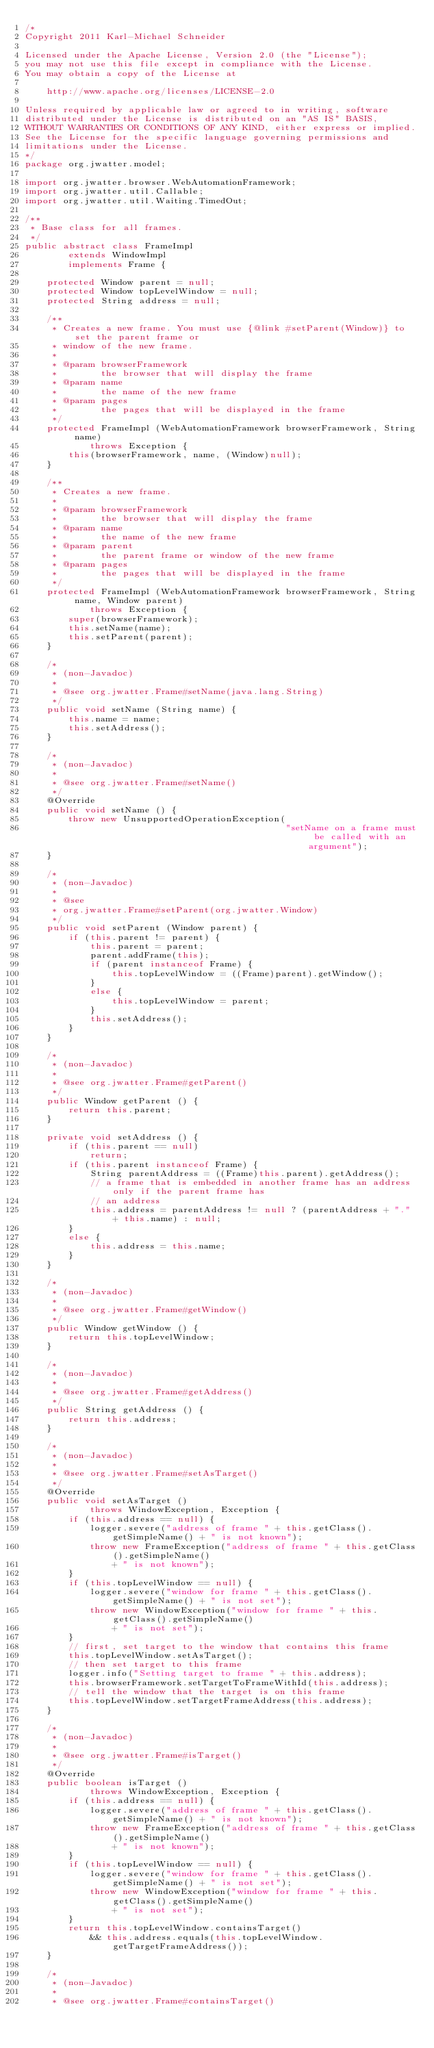Convert code to text. <code><loc_0><loc_0><loc_500><loc_500><_Java_>/*
Copyright 2011 Karl-Michael Schneider

Licensed under the Apache License, Version 2.0 (the "License");
you may not use this file except in compliance with the License.
You may obtain a copy of the License at

    http://www.apache.org/licenses/LICENSE-2.0

Unless required by applicable law or agreed to in writing, software
distributed under the License is distributed on an "AS IS" BASIS,
WITHOUT WARRANTIES OR CONDITIONS OF ANY KIND, either express or implied.
See the License for the specific language governing permissions and
limitations under the License.
*/
package org.jwatter.model;

import org.jwatter.browser.WebAutomationFramework;
import org.jwatter.util.Callable;
import org.jwatter.util.Waiting.TimedOut;

/**
 * Base class for all frames.
 */
public abstract class FrameImpl
        extends WindowImpl
        implements Frame {

    protected Window parent = null;
    protected Window topLevelWindow = null;
    protected String address = null;

    /**
     * Creates a new frame. You must use {@link #setParent(Window)} to set the parent frame or
     * window of the new frame.
     * 
     * @param browserFramework
     *        the browser that will display the frame
     * @param name
     *        the name of the new frame
     * @param pages
     *        the pages that will be displayed in the frame
     */
    protected FrameImpl (WebAutomationFramework browserFramework, String name)
            throws Exception {
        this(browserFramework, name, (Window)null);
    }

    /**
     * Creates a new frame.
     * 
     * @param browserFramework
     *        the browser that will display the frame
     * @param name
     *        the name of the new frame
     * @param parent
     *        the parent frame or window of the new frame
     * @param pages
     *        the pages that will be displayed in the frame
     */
    protected FrameImpl (WebAutomationFramework browserFramework, String name, Window parent)
            throws Exception {
        super(browserFramework);
        this.setName(name);
        this.setParent(parent);
    }

    /*
     * (non-Javadoc)
     * 
     * @see org.jwatter.Frame#setName(java.lang.String)
     */
    public void setName (String name) {
        this.name = name;
        this.setAddress();
    }

    /*
     * (non-Javadoc)
     * 
     * @see org.jwatter.Frame#setName()
     */
    @Override
    public void setName () {
        throw new UnsupportedOperationException(
                                                "setName on a frame must be called with an argument");
    }

    /*
     * (non-Javadoc)
     * 
     * @see
     * org.jwatter.Frame#setParent(org.jwatter.Window)
     */
    public void setParent (Window parent) {
        if (this.parent != parent) {
            this.parent = parent;
            parent.addFrame(this);
            if (parent instanceof Frame) {
                this.topLevelWindow = ((Frame)parent).getWindow();
            }
            else {
                this.topLevelWindow = parent;
            }
            this.setAddress();
        }
    }

    /*
     * (non-Javadoc)
     * 
     * @see org.jwatter.Frame#getParent()
     */
    public Window getParent () {
        return this.parent;
    }

    private void setAddress () {
        if (this.parent == null)
            return;
        if (this.parent instanceof Frame) {
            String parentAddress = ((Frame)this.parent).getAddress();
            // a frame that is embedded in another frame has an address only if the parent frame has
            // an address
            this.address = parentAddress != null ? (parentAddress + "." + this.name) : null;
        }
        else {
            this.address = this.name;
        }
    }

    /*
     * (non-Javadoc)
     * 
     * @see org.jwatter.Frame#getWindow()
     */
    public Window getWindow () {
        return this.topLevelWindow;
    }

    /*
     * (non-Javadoc)
     * 
     * @see org.jwatter.Frame#getAddress()
     */
    public String getAddress () {
        return this.address;
    }

    /*
     * (non-Javadoc)
     * 
     * @see org.jwatter.Frame#setAsTarget()
     */
    @Override
    public void setAsTarget ()
            throws WindowException, Exception {
        if (this.address == null) {
            logger.severe("address of frame " + this.getClass().getSimpleName() + " is not known");
            throw new FrameException("address of frame " + this.getClass().getSimpleName()
                + " is not known");
        }
        if (this.topLevelWindow == null) {
            logger.severe("window for frame " + this.getClass().getSimpleName() + " is not set");
            throw new WindowException("window for frame " + this.getClass().getSimpleName()
                + " is not set");
        }
        // first, set target to the window that contains this frame
        this.topLevelWindow.setAsTarget();
        // then set target to this frame
        logger.info("Setting target to frame " + this.address);
        this.browserFramework.setTargetToFrameWithId(this.address);
        // tell the window that the target is on this frame
        this.topLevelWindow.setTargetFrameAddress(this.address);
    }

    /*
     * (non-Javadoc)
     * 
     * @see org.jwatter.Frame#isTarget()
     */
    @Override
    public boolean isTarget ()
            throws WindowException, Exception {
        if (this.address == null) {
            logger.severe("address of frame " + this.getClass().getSimpleName() + " is not known");
            throw new FrameException("address of frame " + this.getClass().getSimpleName()
                + " is not known");
        }
        if (this.topLevelWindow == null) {
            logger.severe("window for frame " + this.getClass().getSimpleName() + " is not set");
            throw new WindowException("window for frame " + this.getClass().getSimpleName()
                + " is not set");
        }
        return this.topLevelWindow.containsTarget()
            && this.address.equals(this.topLevelWindow.getTargetFrameAddress());
    }

    /*
     * (non-Javadoc)
     * 
     * @see org.jwatter.Frame#containsTarget()</code> 